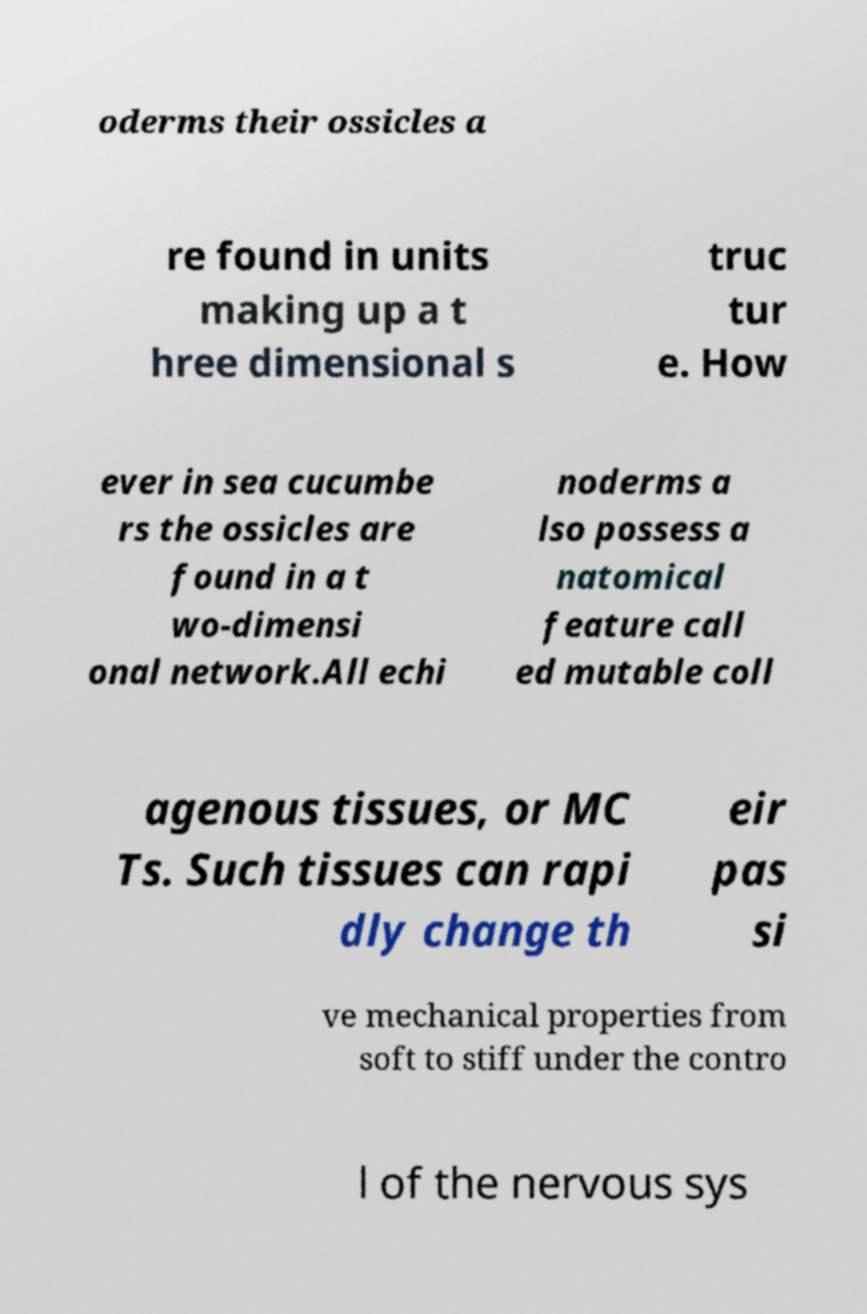Please identify and transcribe the text found in this image. oderms their ossicles a re found in units making up a t hree dimensional s truc tur e. How ever in sea cucumbe rs the ossicles are found in a t wo-dimensi onal network.All echi noderms a lso possess a natomical feature call ed mutable coll agenous tissues, or MC Ts. Such tissues can rapi dly change th eir pas si ve mechanical properties from soft to stiff under the contro l of the nervous sys 